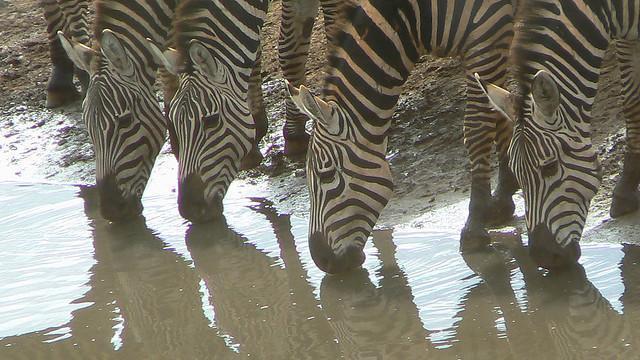How many zebras are there?
Give a very brief answer. 4. How many zebras can be seen?
Give a very brief answer. 5. 